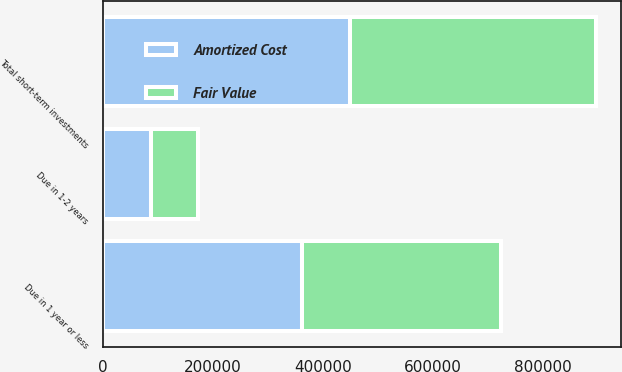Convert chart to OTSL. <chart><loc_0><loc_0><loc_500><loc_500><stacked_bar_chart><ecel><fcel>Due in 1 year or less<fcel>Due in 1-2 years<fcel>Total short-term investments<nl><fcel>Fair Value<fcel>362259<fcel>86682<fcel>448941<nl><fcel>Amortized Cost<fcel>362338<fcel>86594<fcel>448932<nl></chart> 